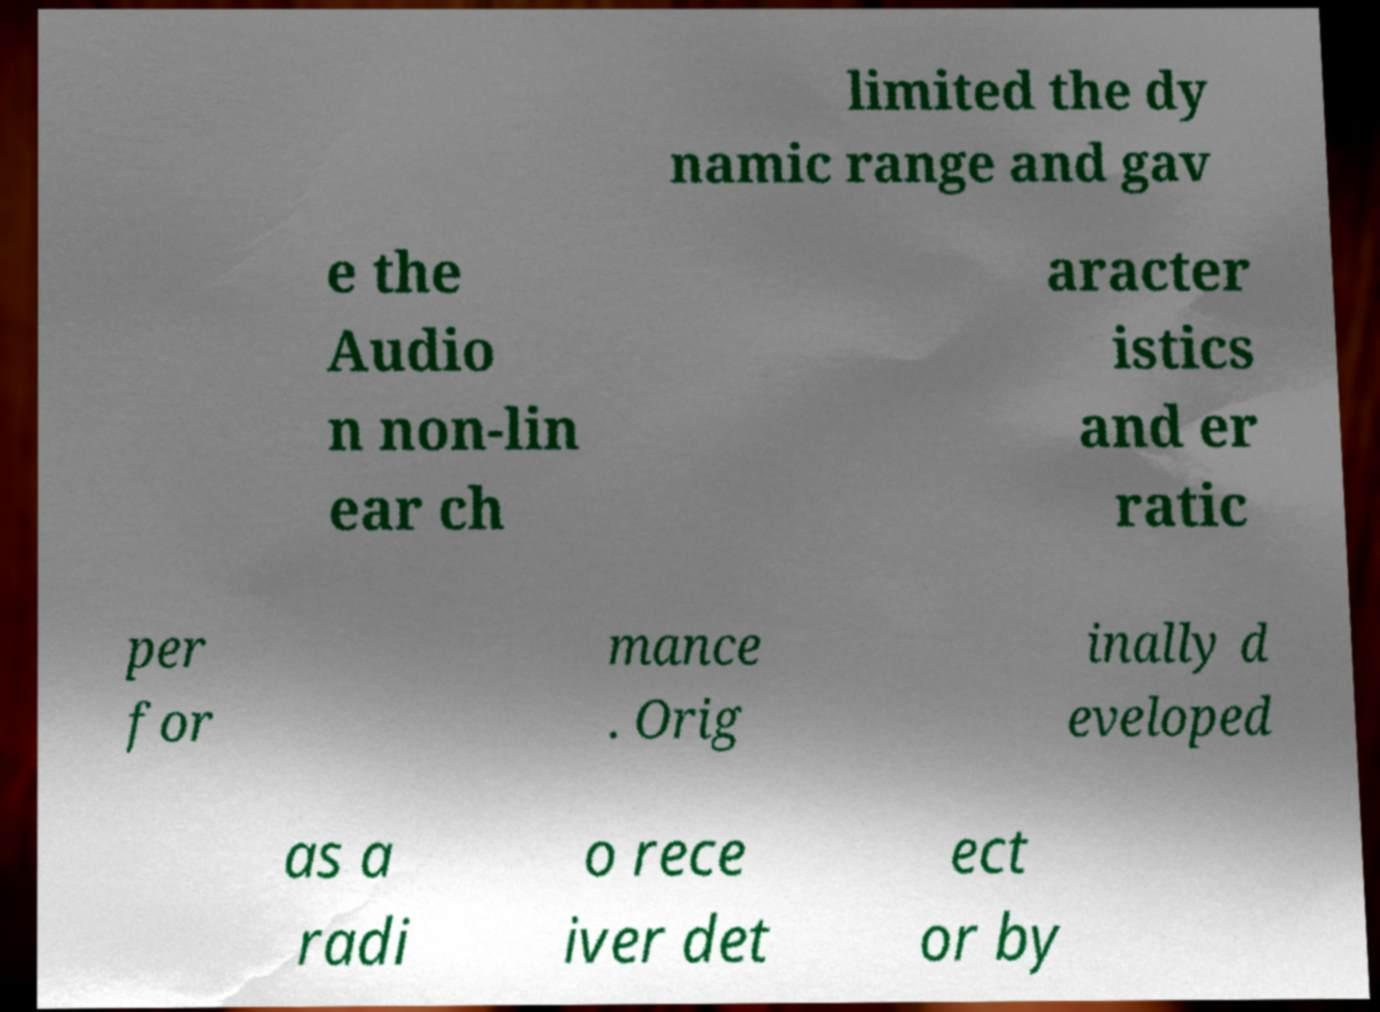There's text embedded in this image that I need extracted. Can you transcribe it verbatim? limited the dy namic range and gav e the Audio n non-lin ear ch aracter istics and er ratic per for mance . Orig inally d eveloped as a radi o rece iver det ect or by 